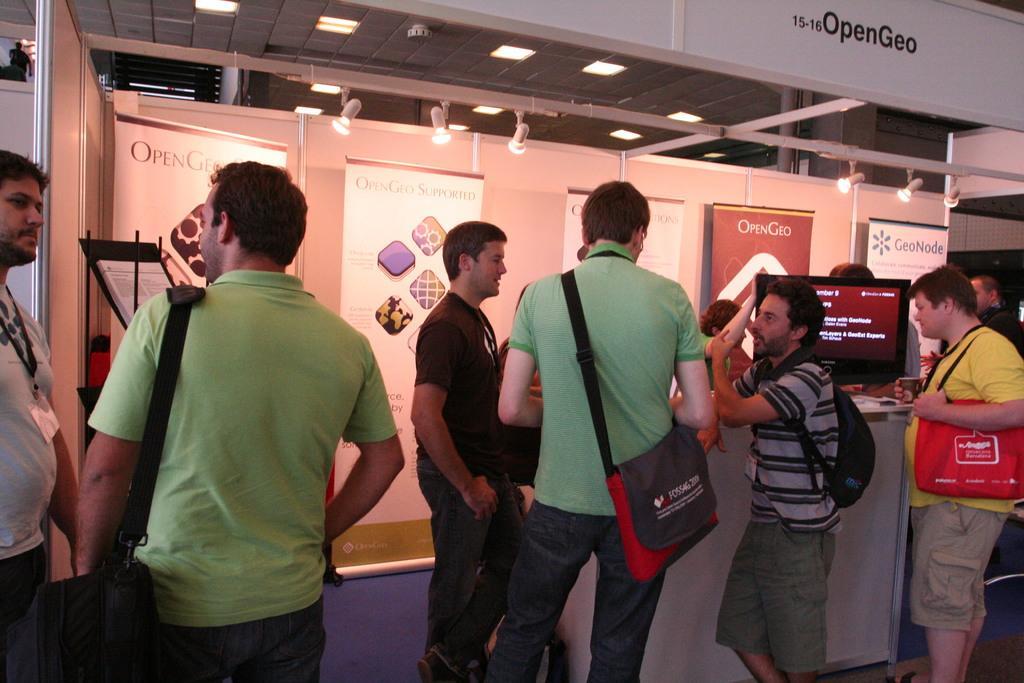Please provide a concise description of this image. There are many people. Some are carrying bags. There is a platform. On that there is a computer. In the back there is a wall with banners. On the ceiling there are lights. 